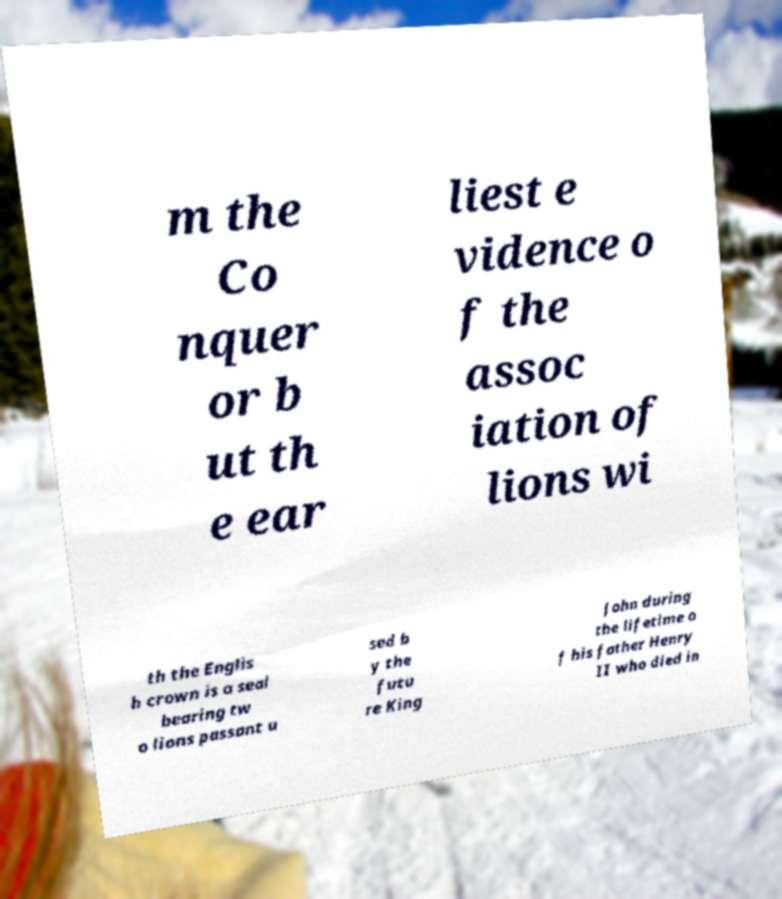Could you extract and type out the text from this image? m the Co nquer or b ut th e ear liest e vidence o f the assoc iation of lions wi th the Englis h crown is a seal bearing tw o lions passant u sed b y the futu re King John during the lifetime o f his father Henry II who died in 